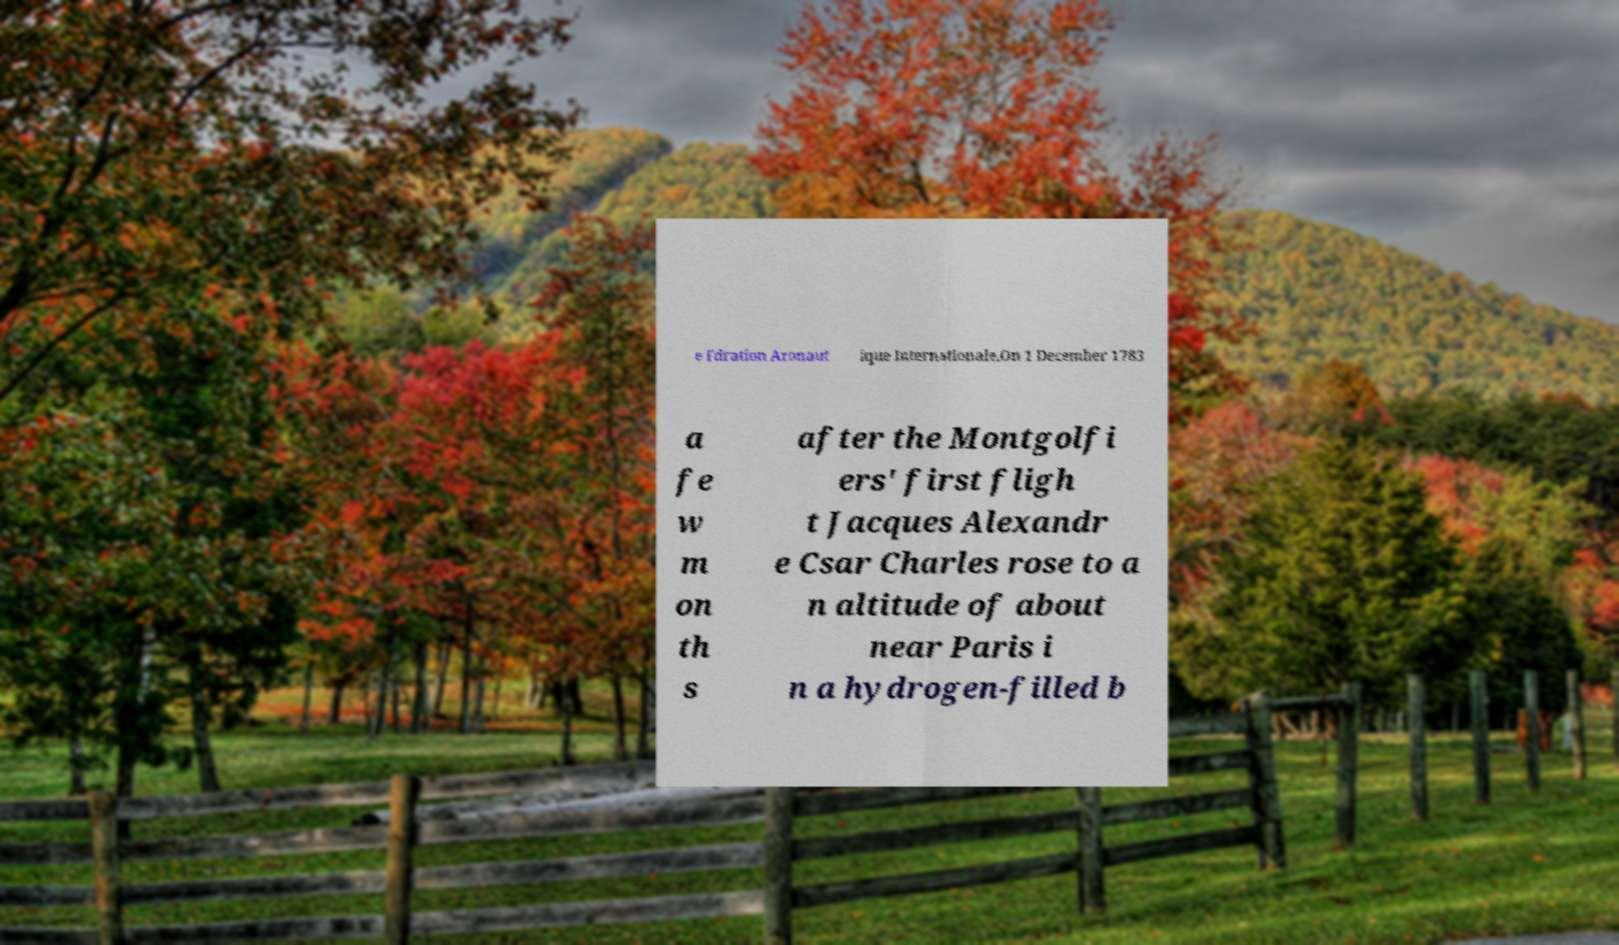Please read and relay the text visible in this image. What does it say? e Fdration Aronaut ique Internationale.On 1 December 1783 a fe w m on th s after the Montgolfi ers' first fligh t Jacques Alexandr e Csar Charles rose to a n altitude of about near Paris i n a hydrogen-filled b 